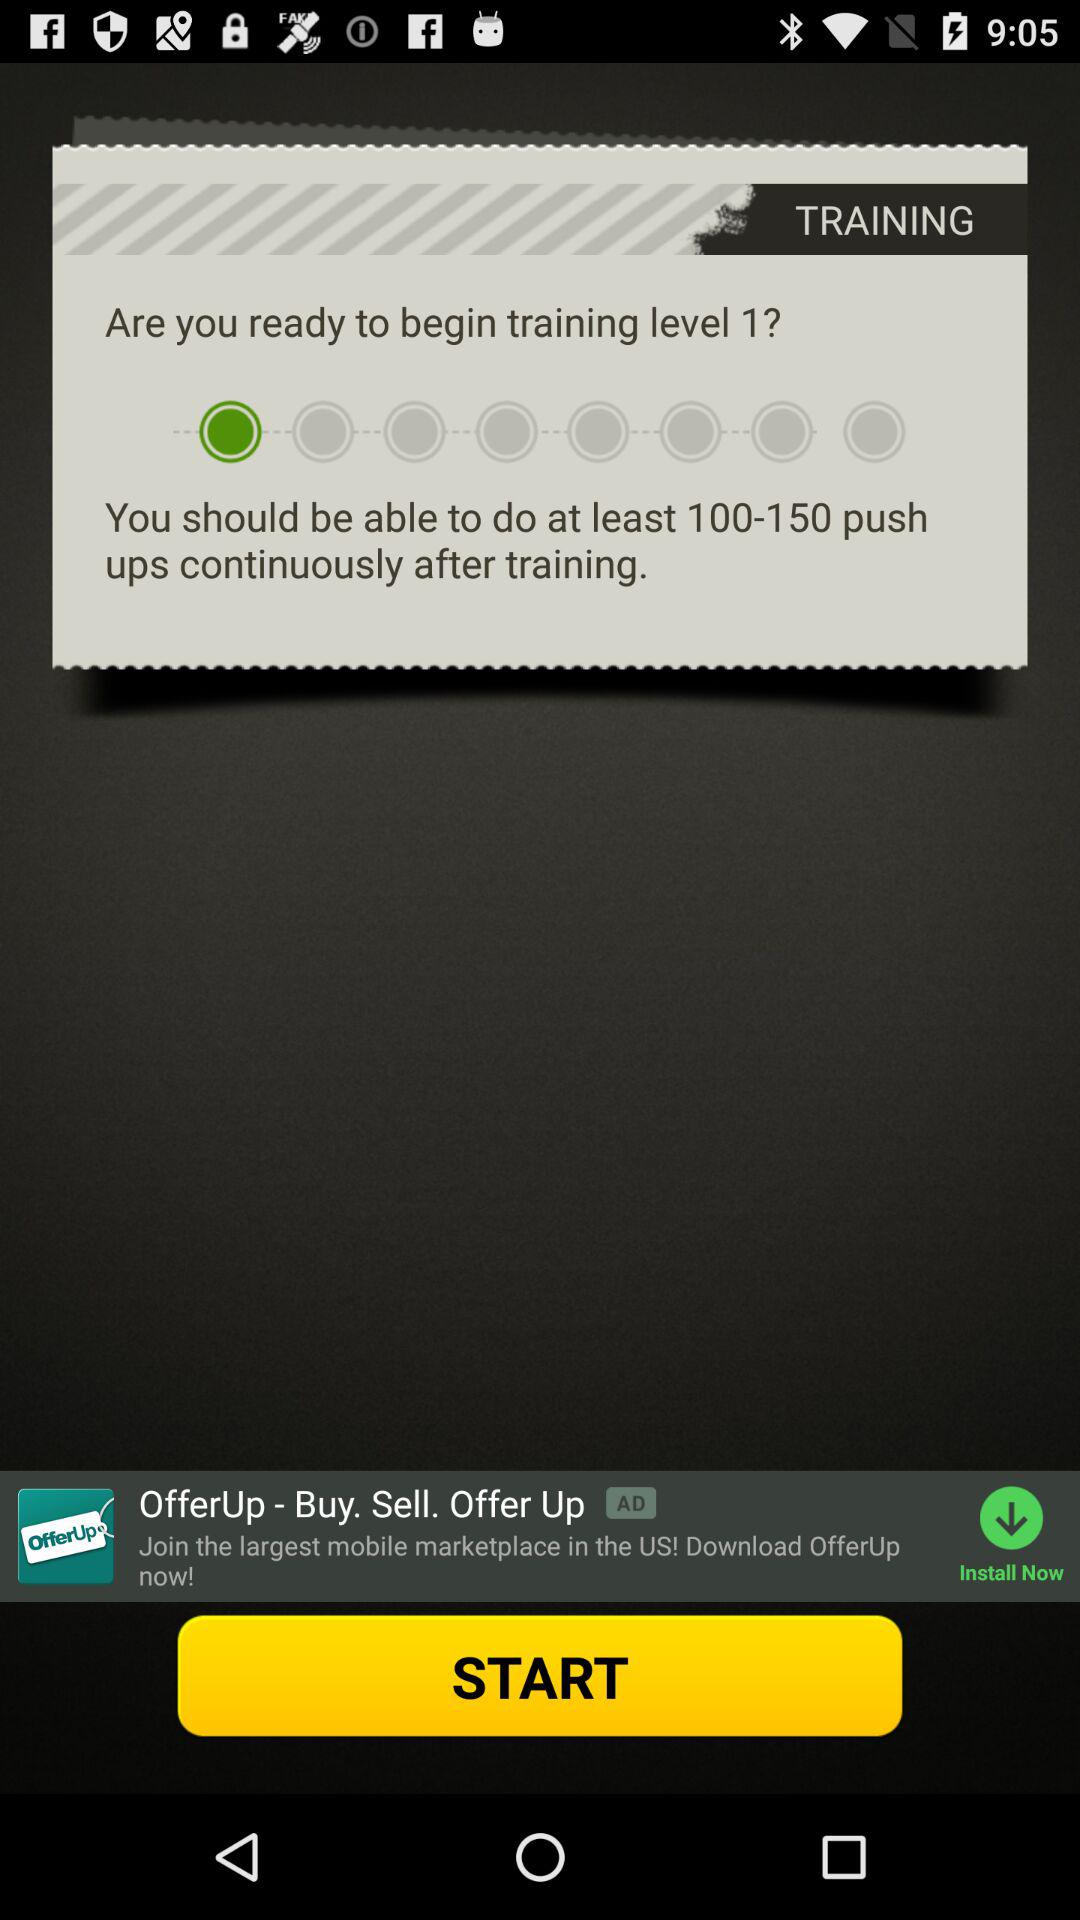What is the training level? The training level is 1. 